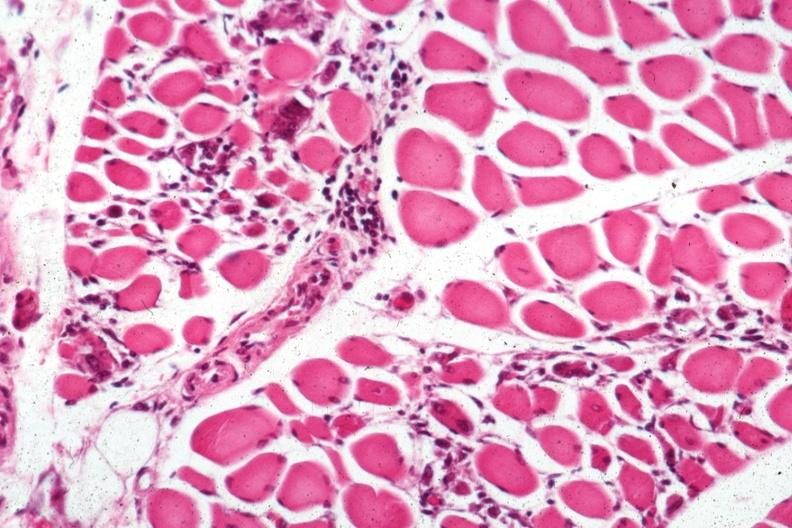what is present?
Answer the question using a single word or phrase. Muscle 